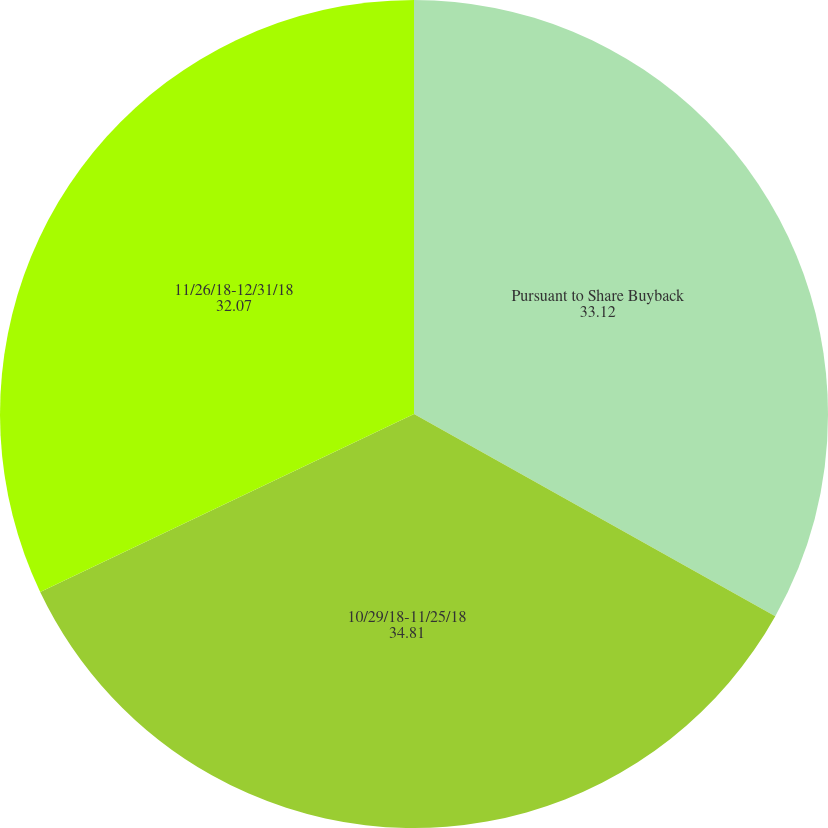Convert chart to OTSL. <chart><loc_0><loc_0><loc_500><loc_500><pie_chart><fcel>Pursuant to Share Buyback<fcel>10/29/18-11/25/18<fcel>11/26/18-12/31/18<nl><fcel>33.12%<fcel>34.81%<fcel>32.07%<nl></chart> 